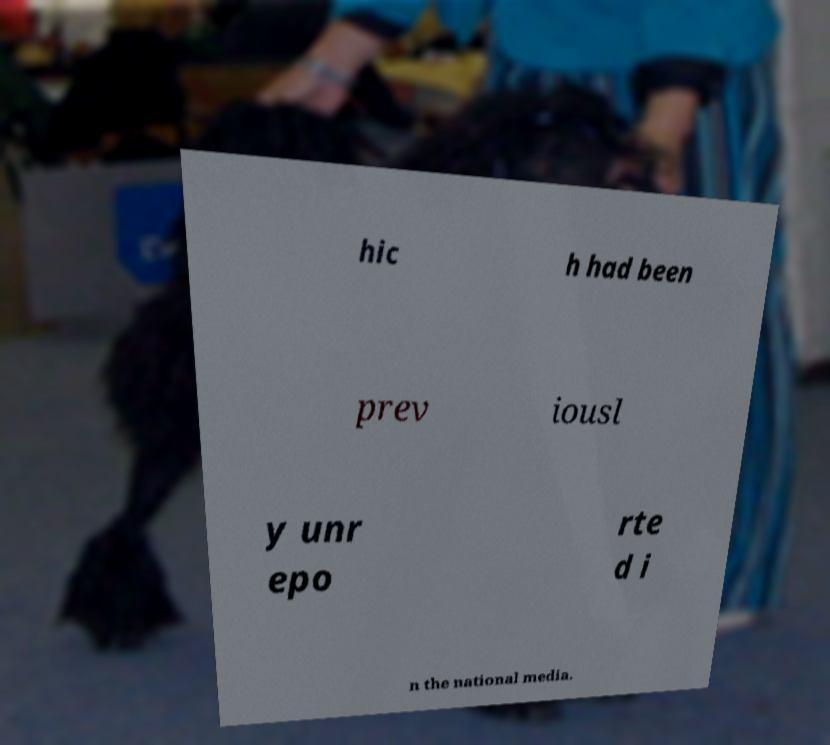There's text embedded in this image that I need extracted. Can you transcribe it verbatim? hic h had been prev iousl y unr epo rte d i n the national media. 